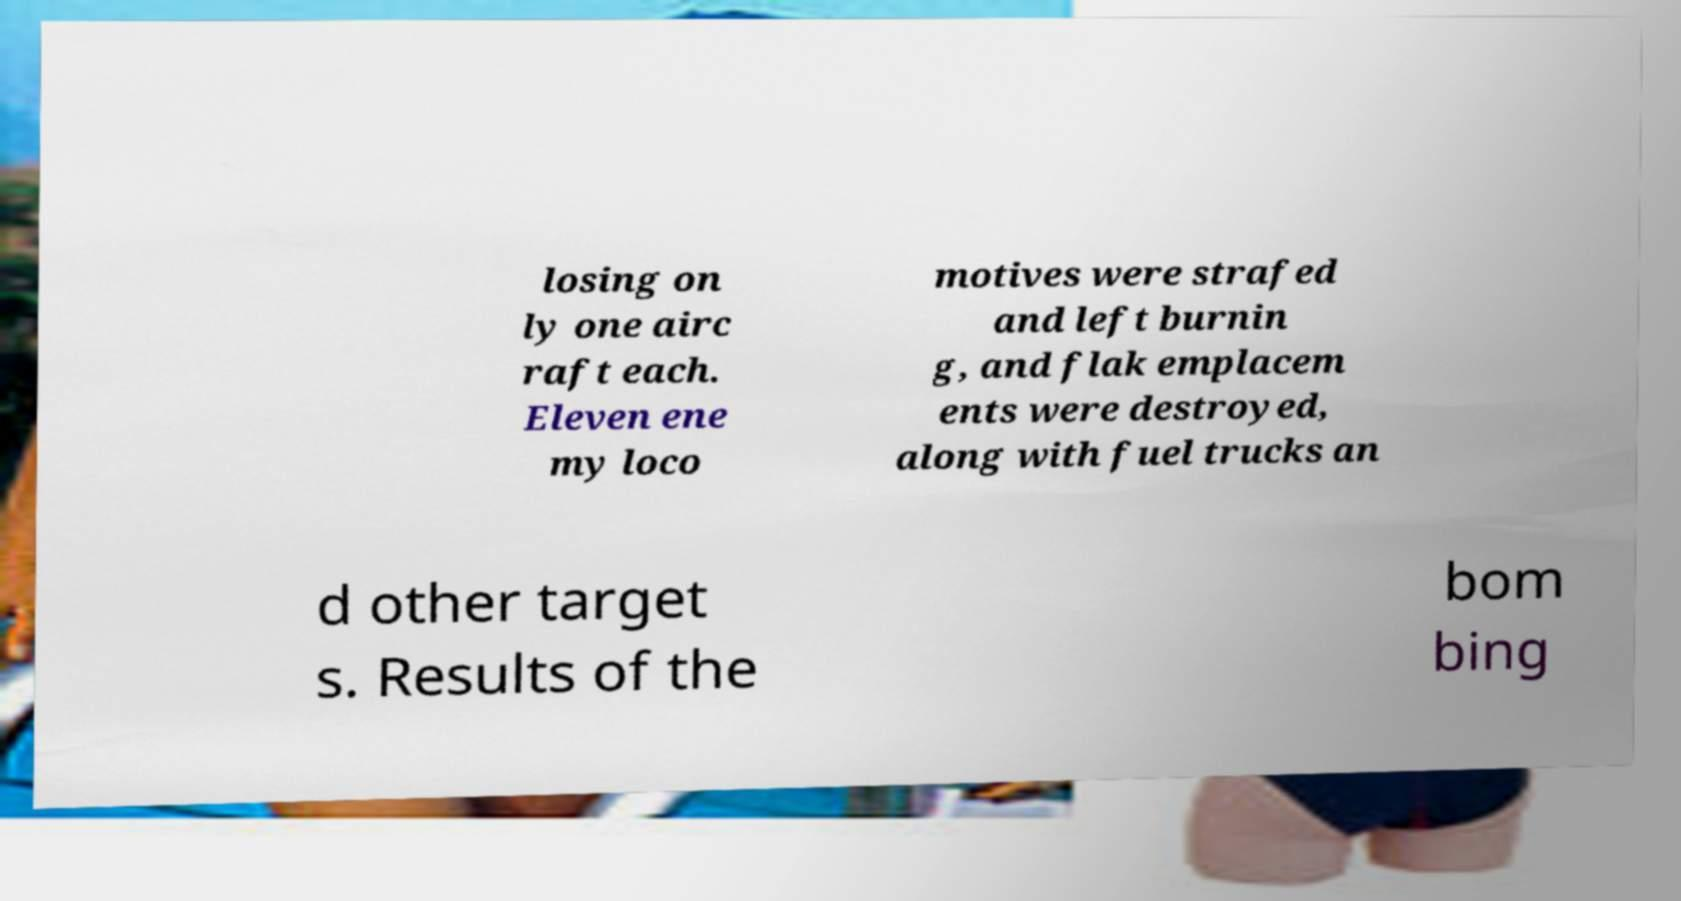Can you read and provide the text displayed in the image?This photo seems to have some interesting text. Can you extract and type it out for me? losing on ly one airc raft each. Eleven ene my loco motives were strafed and left burnin g, and flak emplacem ents were destroyed, along with fuel trucks an d other target s. Results of the bom bing 